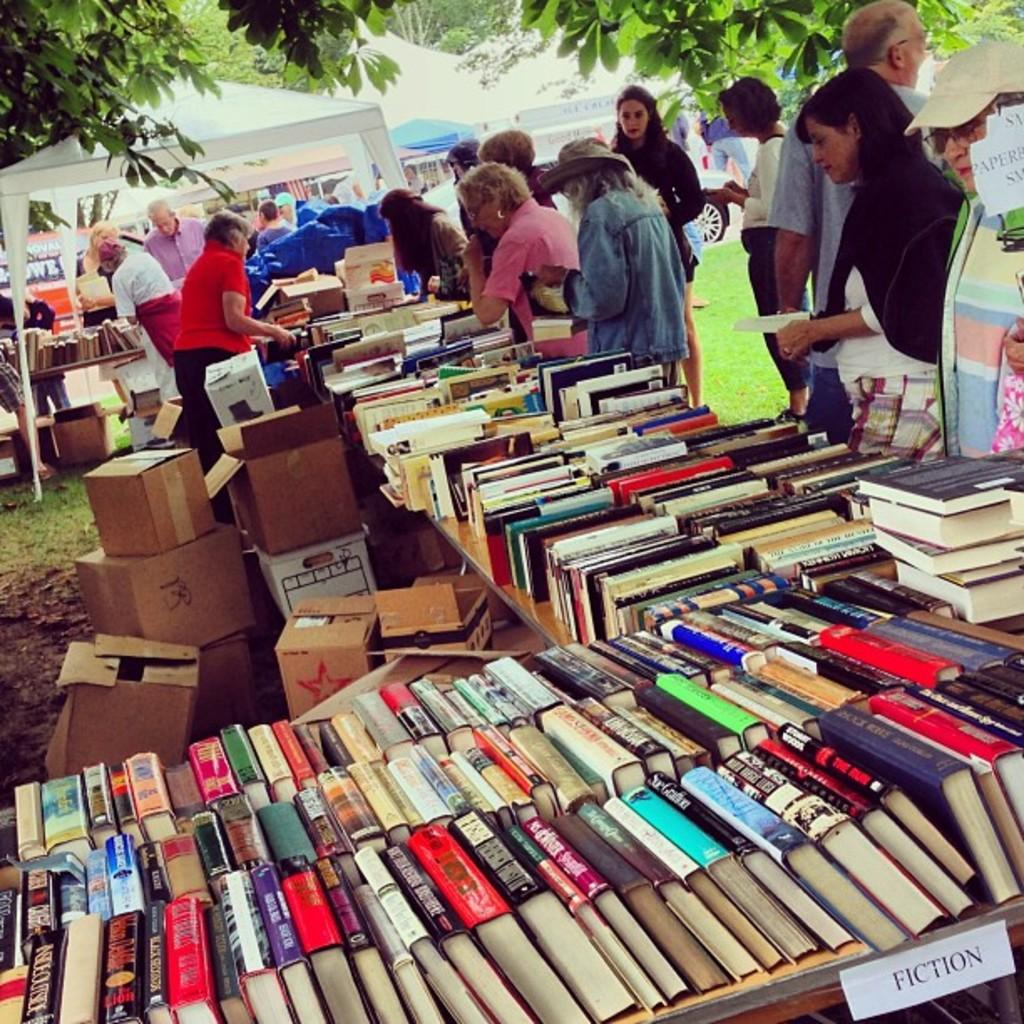<image>
Write a terse but informative summary of the picture. People browse books for sale at a flea market - one table is labeled FICTION 